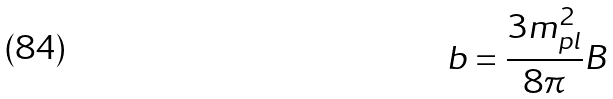Convert formula to latex. <formula><loc_0><loc_0><loc_500><loc_500>b = \frac { 3 m _ { p l } ^ { 2 } } { 8 \pi } B</formula> 